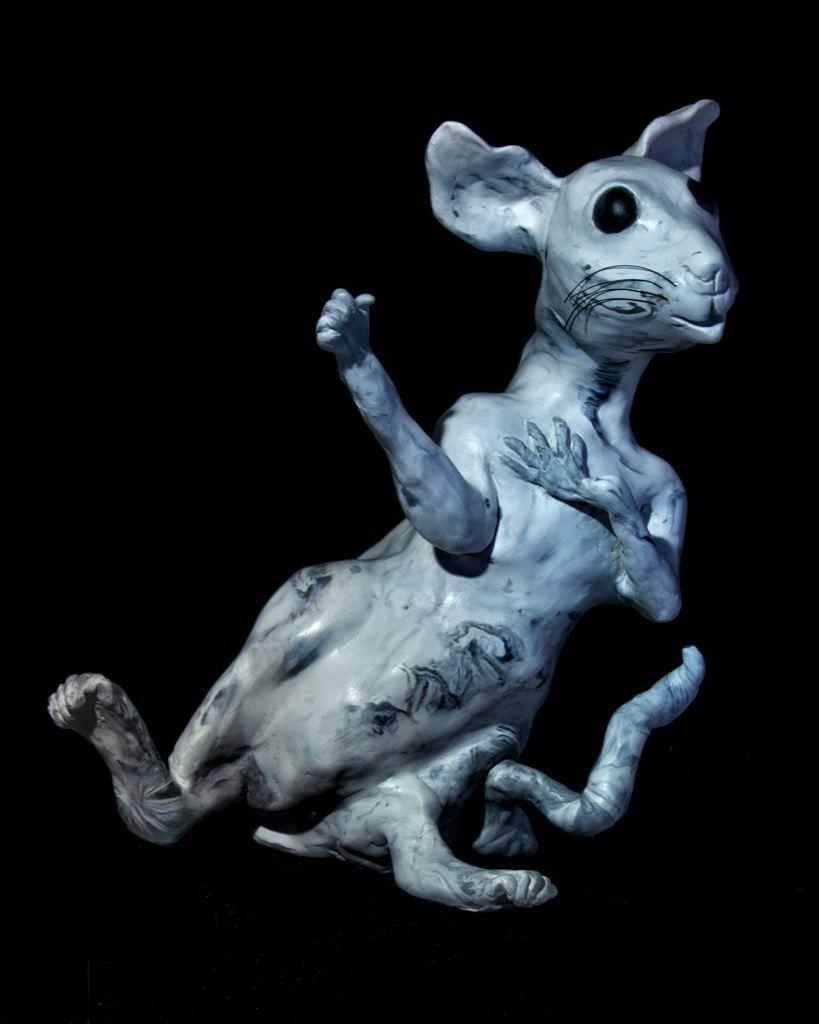What is the main subject of the picture? The main subject of the picture is a statue of an animal. Can you describe the background of the image? The background of the image appears to be dark. What type of wood is used to make the chess pieces in the image? There are no chess pieces present in the image, so it is not possible to determine what type of wood they might be made of. 